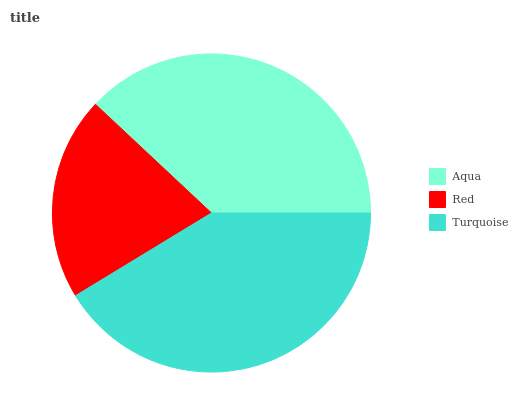Is Red the minimum?
Answer yes or no. Yes. Is Turquoise the maximum?
Answer yes or no. Yes. Is Turquoise the minimum?
Answer yes or no. No. Is Red the maximum?
Answer yes or no. No. Is Turquoise greater than Red?
Answer yes or no. Yes. Is Red less than Turquoise?
Answer yes or no. Yes. Is Red greater than Turquoise?
Answer yes or no. No. Is Turquoise less than Red?
Answer yes or no. No. Is Aqua the high median?
Answer yes or no. Yes. Is Aqua the low median?
Answer yes or no. Yes. Is Turquoise the high median?
Answer yes or no. No. Is Turquoise the low median?
Answer yes or no. No. 